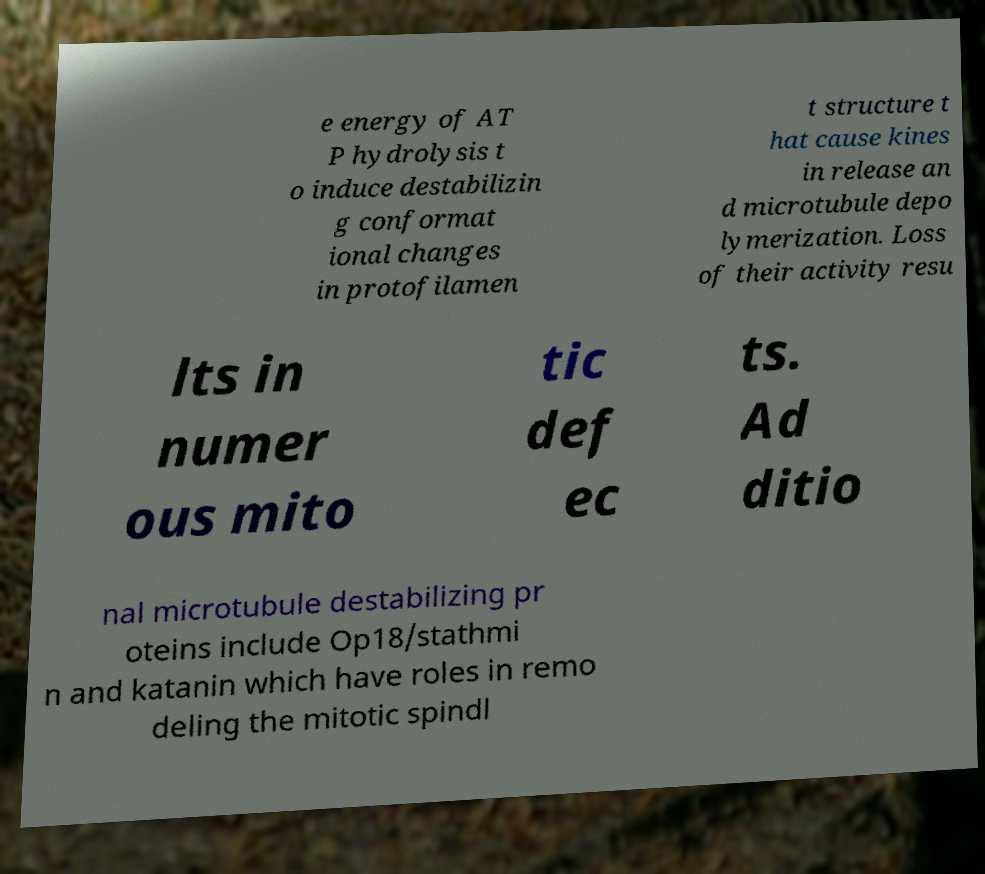What messages or text are displayed in this image? I need them in a readable, typed format. e energy of AT P hydrolysis t o induce destabilizin g conformat ional changes in protofilamen t structure t hat cause kines in release an d microtubule depo lymerization. Loss of their activity resu lts in numer ous mito tic def ec ts. Ad ditio nal microtubule destabilizing pr oteins include Op18/stathmi n and katanin which have roles in remo deling the mitotic spindl 